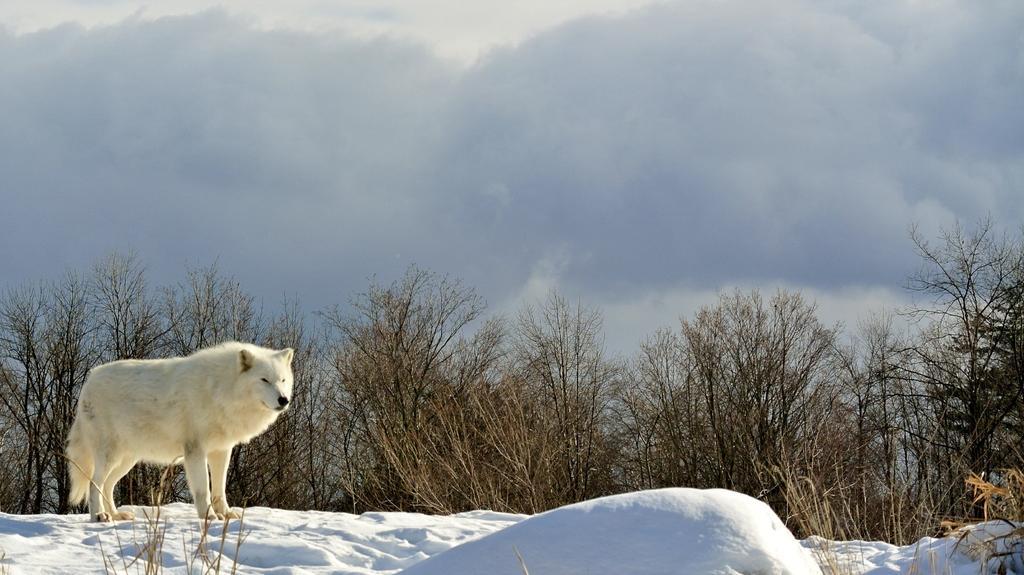How would you summarize this image in a sentence or two? In the picture I can see a wolf on the left side. I can see the snow at the bottom of the image. In the background, I can see the trees. The sky is cloudy. 